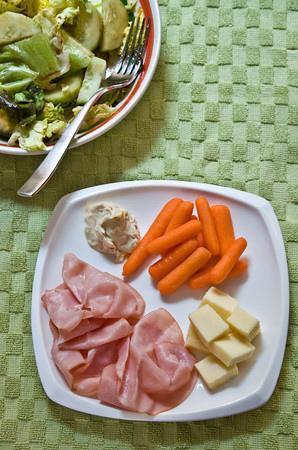Which corner of the plate contains meat?
Answer the question by selecting the correct answer among the 4 following choices and explain your choice with a short sentence. The answer should be formatted with the following format: `Answer: choice
Rationale: rationale.`
Options: Top right, bottom left, bottom right, top left. Answer: bottom left.
Rationale: That area holds thinly sliced carnivore treats.  the other three corners have vegetarian fare. 